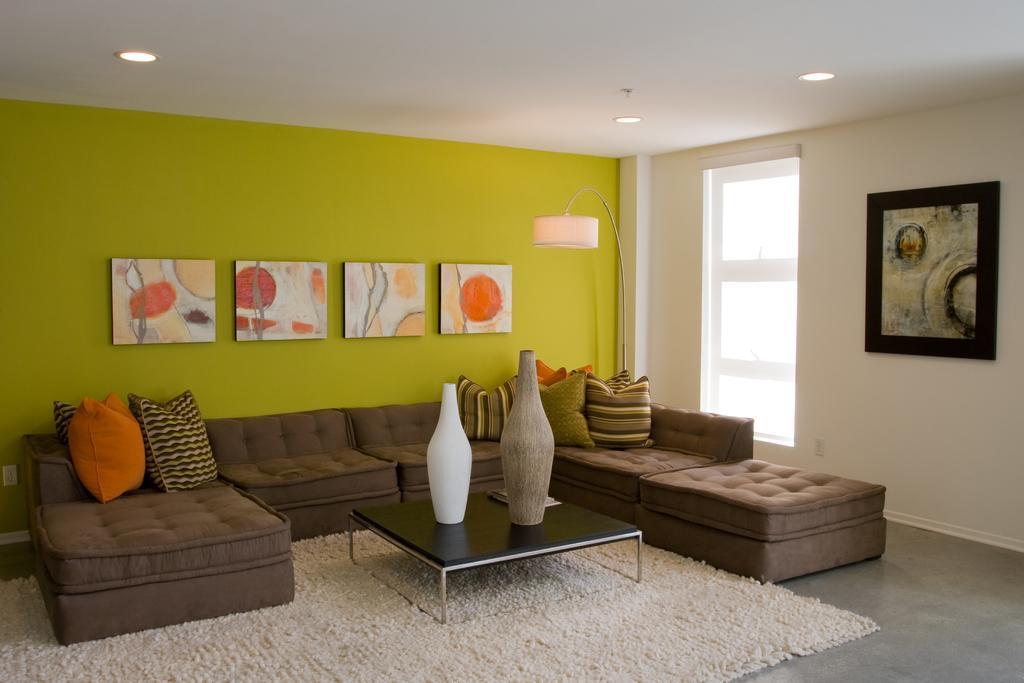Could you give a brief overview of what you see in this image? As we can see in the image there is a green color wall, lamp, window, photo frame, sofas and pillows and in front of sofa there is a table. On table there are pots. 